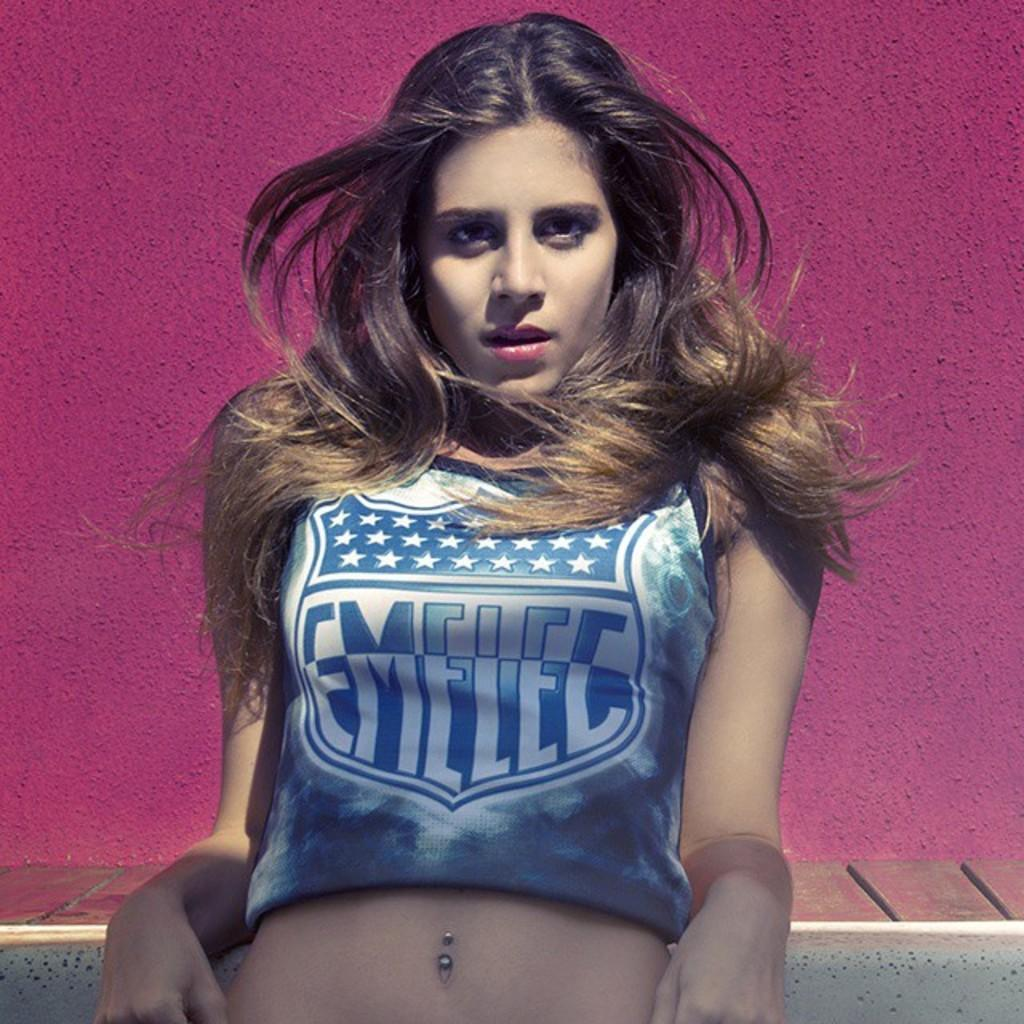<image>
Give a short and clear explanation of the subsequent image. A woman is wearing a shirt that says EMELEC on it. 